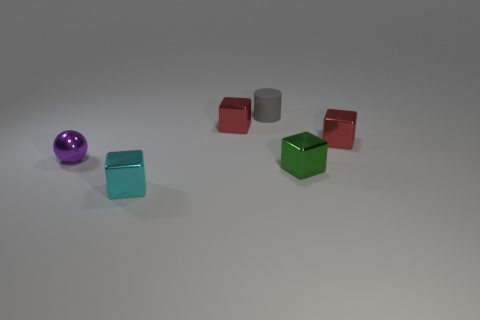How many other objects are the same shape as the small green metallic thing?
Provide a short and direct response. 3. How many objects are tiny metal objects that are to the right of the shiny ball or shiny things behind the shiny sphere?
Offer a very short reply. 4. How many other things are there of the same color as the tiny rubber object?
Give a very brief answer. 0. Is the number of matte things in front of the tiny cyan thing less than the number of gray matte things on the left side of the small green metallic object?
Keep it short and to the point. Yes. What number of large blue cylinders are there?
Your response must be concise. 0. Is there anything else that is the same material as the small gray cylinder?
Ensure brevity in your answer.  No. There is a small cyan thing that is the same shape as the green object; what is it made of?
Offer a terse response. Metal. Are there fewer red things on the left side of the cyan metal thing than cubes?
Provide a short and direct response. Yes. There is a small red object to the right of the small cylinder; is its shape the same as the small green thing?
Ensure brevity in your answer.  Yes. There is a block behind the red metal cube that is in front of the tiny red thing that is on the left side of the gray object; what is it made of?
Make the answer very short. Metal. 